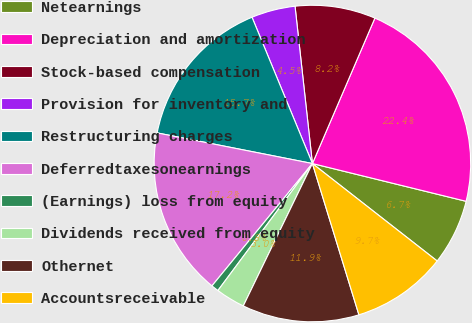Convert chart. <chart><loc_0><loc_0><loc_500><loc_500><pie_chart><fcel>Netearnings<fcel>Depreciation and amortization<fcel>Stock-based compensation<fcel>Provision for inventory and<fcel>Restructuring charges<fcel>Deferredtaxesonearnings<fcel>(Earnings) loss from equity<fcel>Dividends received from equity<fcel>Othernet<fcel>Accountsreceivable<nl><fcel>6.72%<fcel>22.38%<fcel>8.21%<fcel>4.48%<fcel>15.67%<fcel>17.16%<fcel>0.76%<fcel>2.99%<fcel>11.94%<fcel>9.7%<nl></chart> 